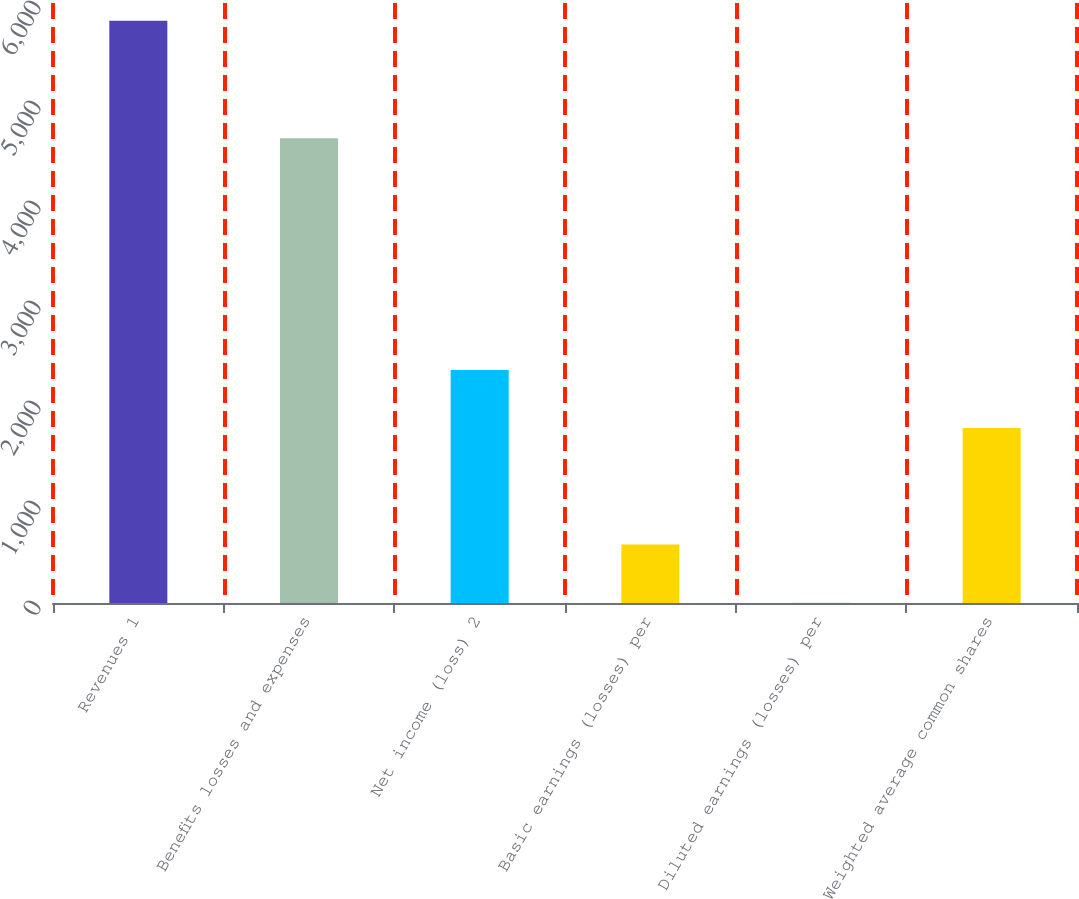Convert chart to OTSL. <chart><loc_0><loc_0><loc_500><loc_500><bar_chart><fcel>Revenues 1<fcel>Benefits losses and expenses<fcel>Net income (loss) 2<fcel>Basic earnings (losses) per<fcel>Diluted earnings (losses) per<fcel>Weighted average common shares<nl><fcel>5823<fcel>4648<fcel>2330.8<fcel>584.71<fcel>2.68<fcel>1748.77<nl></chart> 